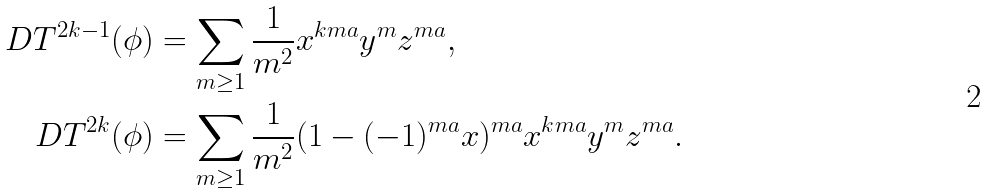Convert formula to latex. <formula><loc_0><loc_0><loc_500><loc_500>\ D T ^ { 2 k - 1 } ( \phi ) & = \sum _ { m \geq 1 } \frac { 1 } { m ^ { 2 } } x ^ { k m a } y ^ { m } z ^ { m a } , \\ \ D T ^ { 2 k } ( \phi ) & = \sum _ { m \geq 1 } \frac { 1 } { m ^ { 2 } } ( 1 - ( - 1 ) ^ { m a } x ) ^ { m a } x ^ { k m a } y ^ { m } z ^ { m a } .</formula> 